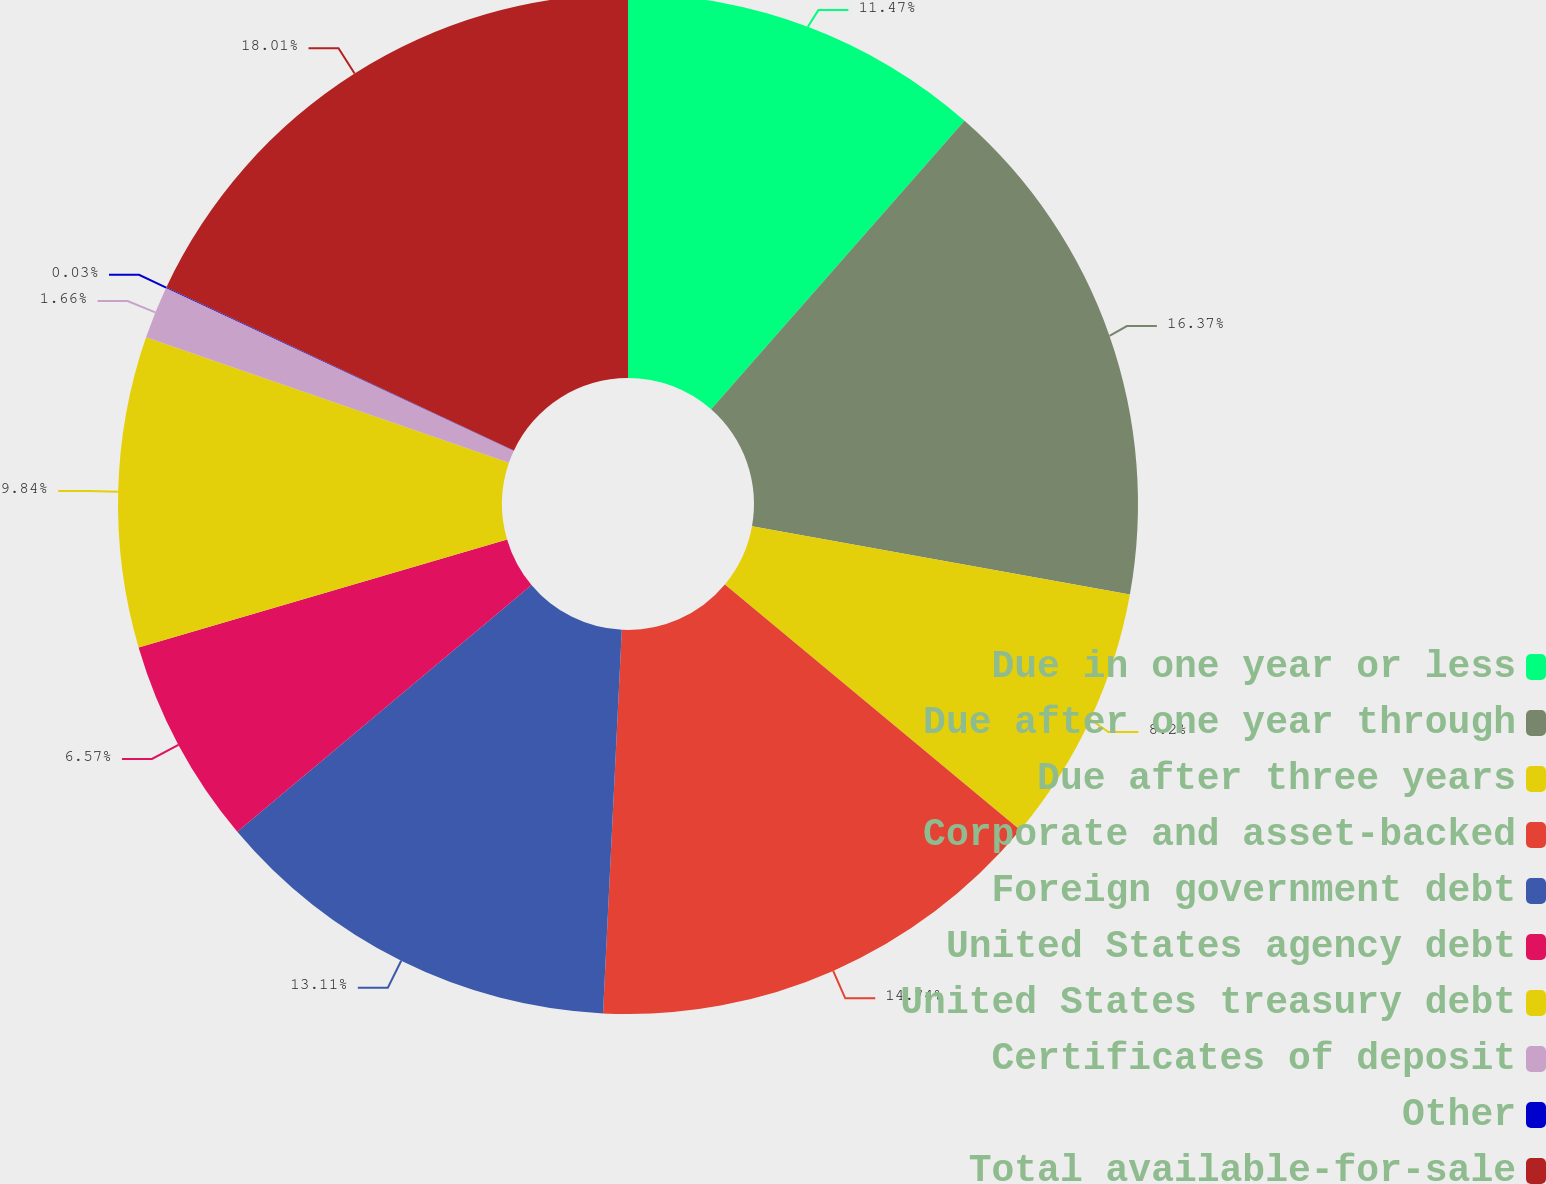<chart> <loc_0><loc_0><loc_500><loc_500><pie_chart><fcel>Due in one year or less<fcel>Due after one year through<fcel>Due after three years<fcel>Corporate and asset-backed<fcel>Foreign government debt<fcel>United States agency debt<fcel>United States treasury debt<fcel>Certificates of deposit<fcel>Other<fcel>Total available-for-sale<nl><fcel>11.47%<fcel>16.37%<fcel>8.2%<fcel>14.74%<fcel>13.11%<fcel>6.57%<fcel>9.84%<fcel>1.66%<fcel>0.03%<fcel>18.01%<nl></chart> 